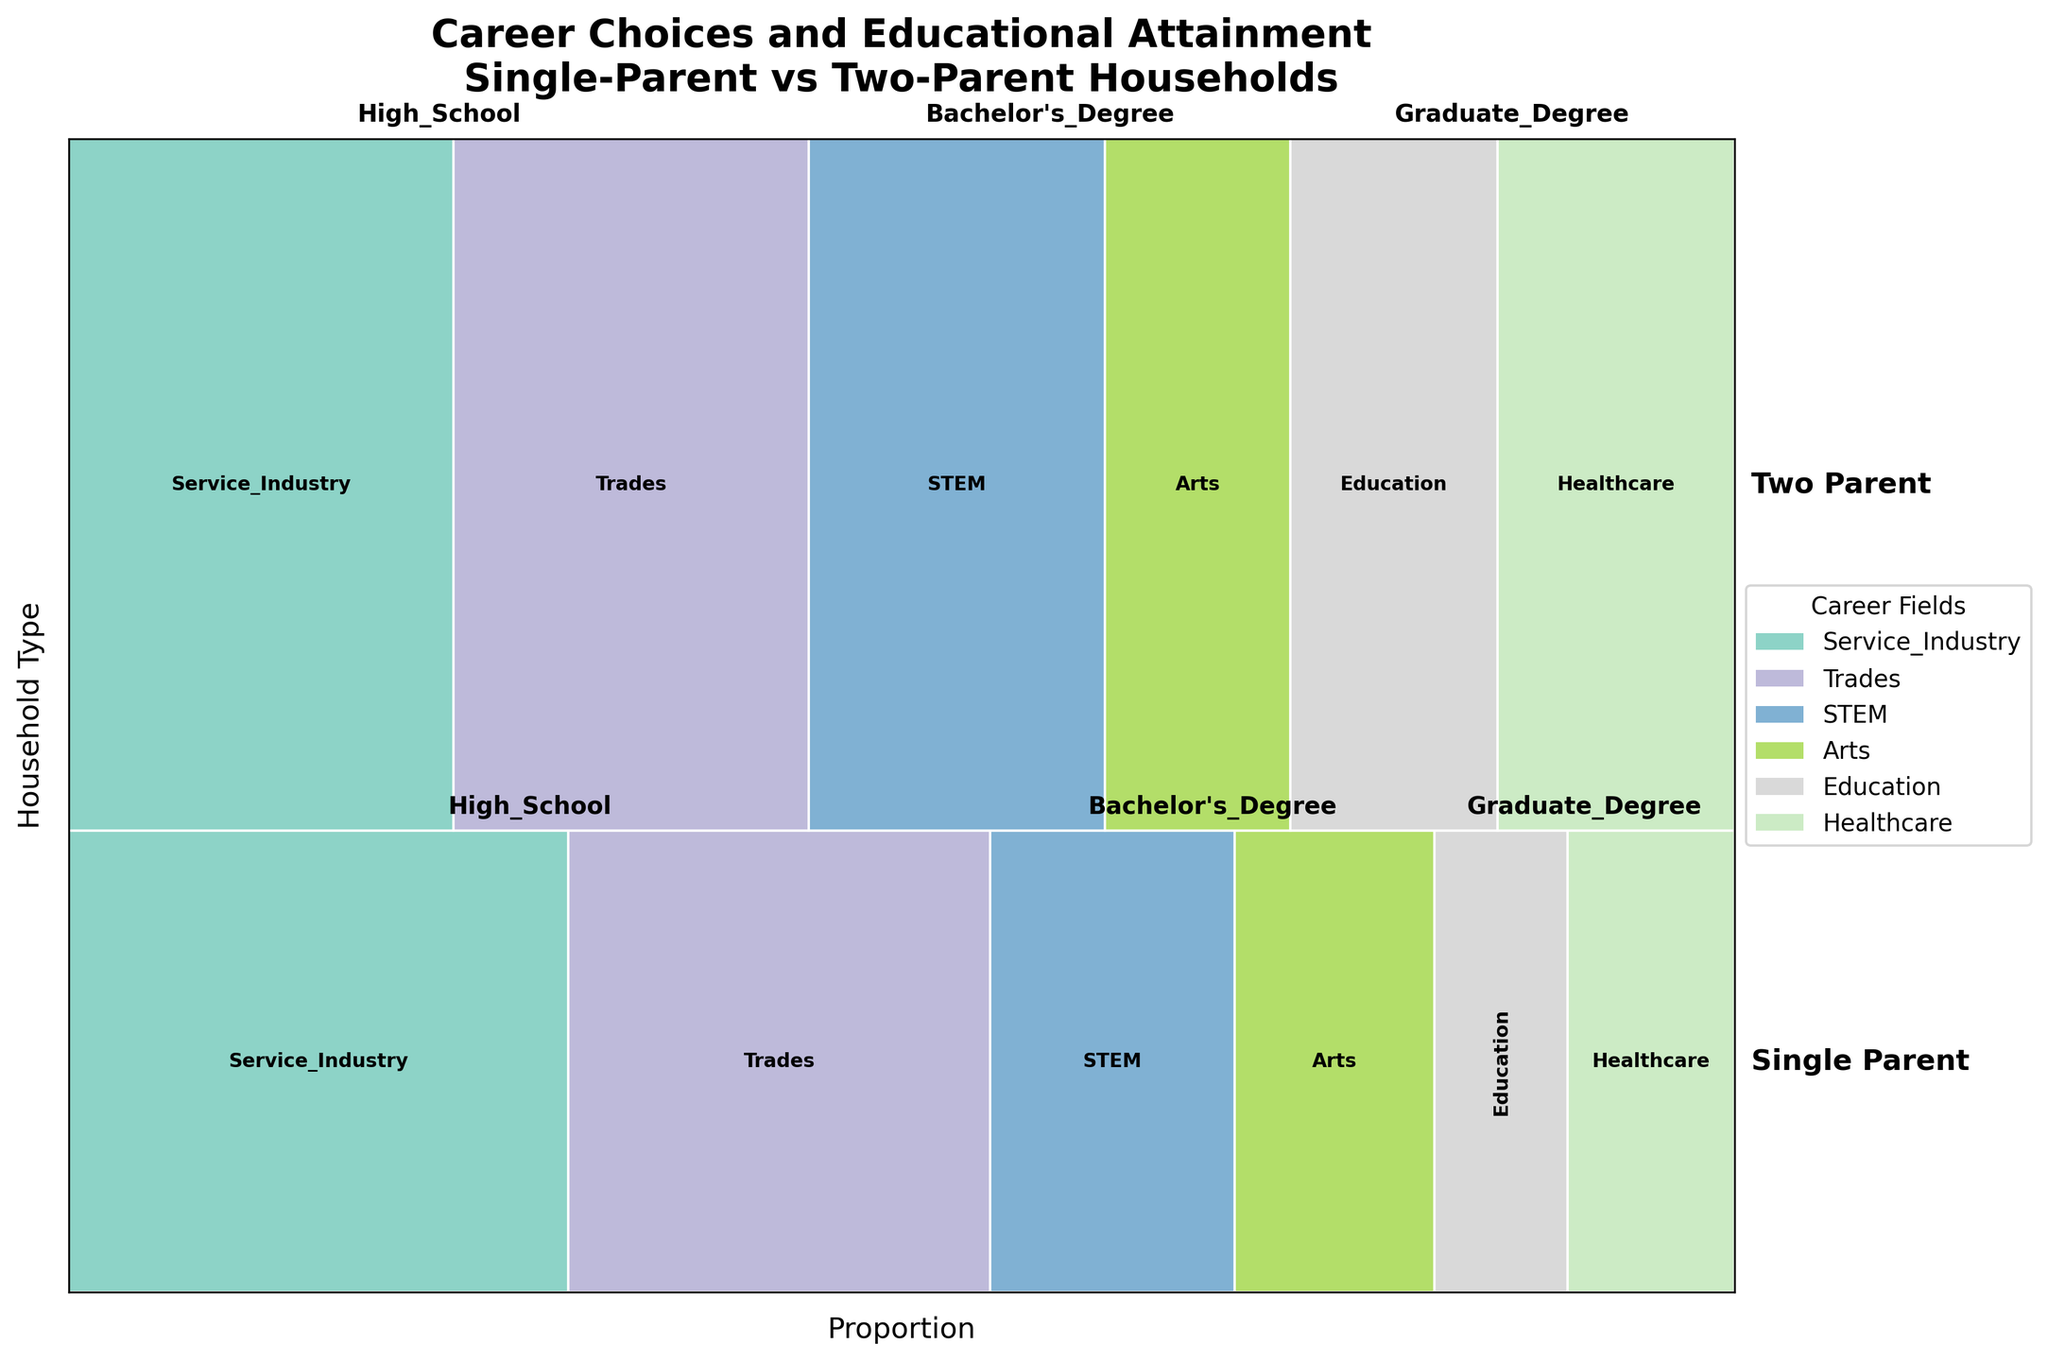Which household type is displayed on the left side of the plot? The plot places "Single-Parent" households on the left side. This can be identified because, in the figure, all related rectangles and texts for "Single-Parent" households are situated to the left, whereas "Two-Parent" households are on the right.
Answer: Single-Parent What is the career field with the highest proportion among those with a bachelor's degree in single-parent households? We first locate the "Bachelor's Degree" category for "Single-Parent" households, then check the career fields within that category. "STEM" has the largest portion of the corresponding area.
Answer: STEM Compare the proportion of individuals in the healthcare field with a graduate degree between single-parent and two-parent households. Which proportion is higher? By comparing the size of the rectangles for "Healthcare" under "Graduate Degree" between the two household types, the area for "Two-Parent" households is visibly larger than that for "Single-Parent" households.
Answer: Two-Parent For "High School" education, what career field has a larger proportion in single-parent households than in two-parent households? By comparing the "Service Industry" and "Trades" rectangles under "High School" education for both types of households, we find that "Service Industry" occupies a larger area in single-parent households compared to two-parent households.
Answer: Service Industry Among individuals with a "Bachelor's Degree," which career field is less common in two-parent households compared to single-parent households? Examining the "Bachelor's Degree" category, the "Arts" field has a smaller area in two-parent households compared to single-parent households.
Answer: Arts Which education level in single-parent households has the smallest proportion of individuals in STEM careers? Checking the rectangles for "STEM" in "High School," "Bachelor's Degree," and "Graduate Degree" categories for single-parent households, "Graduate Degree" reveals the smallest area.
Answer: Graduate Degree What career appears in all education levels in both household types? By looking at the career fields present in each education level for both household types, we see that "Service Industry" is represented across "High School," "Bachelor's Degree," and "Graduate Degree" for both Single-Parent and Two-Parent.
Answer: Service Industry Determine the total proportion of individuals in the trades field across all education levels from single-parent households. Is it greater or less than the same field in two-parent households? Adding up the proportions (sizes of rectangles) for "Trades" under each education level in single-parent households, we then do the same for two-parent households. Comparing the two sums, single-parent households have a smaller combined area for "Trades."
Answer: Less 